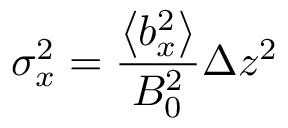<formula> <loc_0><loc_0><loc_500><loc_500>\sigma _ { x } ^ { 2 } = \frac { \left \langle b _ { x } ^ { 2 } \right \rangle } { B _ { 0 } ^ { 2 } } \Delta z ^ { 2 }</formula> 